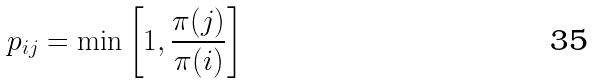<formula> <loc_0><loc_0><loc_500><loc_500>p _ { i j } = \min \left [ 1 , \frac { \pi ( j ) } { \pi ( i ) } \right ]</formula> 